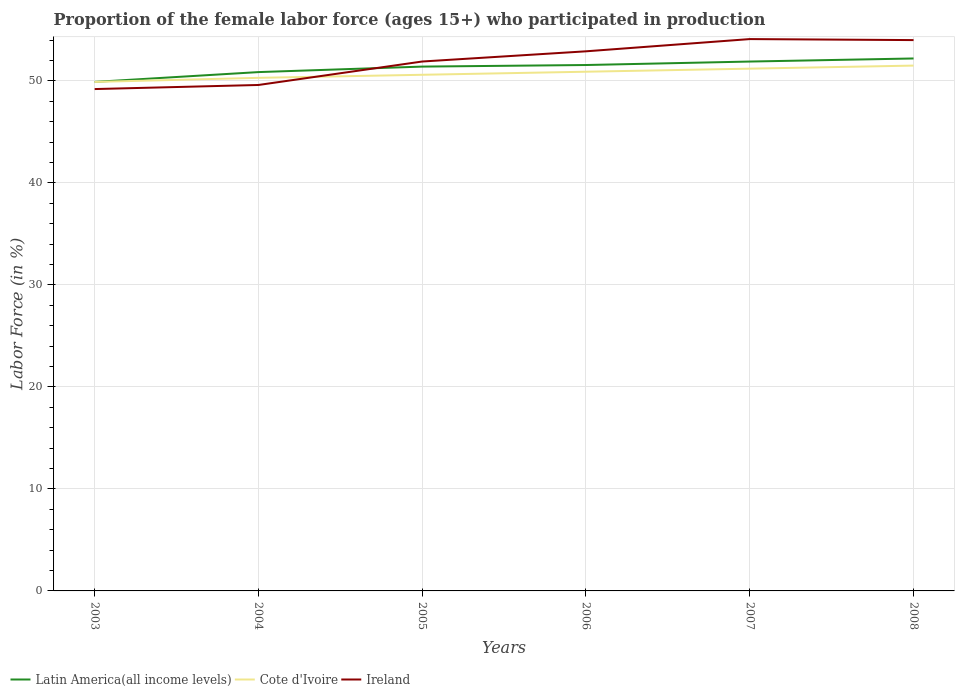Does the line corresponding to Ireland intersect with the line corresponding to Cote d'Ivoire?
Give a very brief answer. Yes. Across all years, what is the maximum proportion of the female labor force who participated in production in Cote d'Ivoire?
Your response must be concise. 49.9. In which year was the proportion of the female labor force who participated in production in Cote d'Ivoire maximum?
Provide a succinct answer. 2003. What is the total proportion of the female labor force who participated in production in Cote d'Ivoire in the graph?
Ensure brevity in your answer.  -0.4. What is the difference between the highest and the second highest proportion of the female labor force who participated in production in Ireland?
Keep it short and to the point. 4.9. What is the difference between the highest and the lowest proportion of the female labor force who participated in production in Cote d'Ivoire?
Make the answer very short. 3. How many years are there in the graph?
Offer a terse response. 6. What is the difference between two consecutive major ticks on the Y-axis?
Offer a terse response. 10. Are the values on the major ticks of Y-axis written in scientific E-notation?
Your answer should be very brief. No. Where does the legend appear in the graph?
Give a very brief answer. Bottom left. What is the title of the graph?
Offer a terse response. Proportion of the female labor force (ages 15+) who participated in production. Does "Moldova" appear as one of the legend labels in the graph?
Your response must be concise. No. What is the label or title of the X-axis?
Give a very brief answer. Years. What is the Labor Force (in %) in Latin America(all income levels) in 2003?
Provide a succinct answer. 49.9. What is the Labor Force (in %) in Cote d'Ivoire in 2003?
Offer a very short reply. 49.9. What is the Labor Force (in %) in Ireland in 2003?
Provide a succinct answer. 49.2. What is the Labor Force (in %) in Latin America(all income levels) in 2004?
Ensure brevity in your answer.  50.86. What is the Labor Force (in %) of Cote d'Ivoire in 2004?
Offer a very short reply. 50.3. What is the Labor Force (in %) of Ireland in 2004?
Offer a terse response. 49.6. What is the Labor Force (in %) in Latin America(all income levels) in 2005?
Offer a very short reply. 51.4. What is the Labor Force (in %) in Cote d'Ivoire in 2005?
Your answer should be very brief. 50.6. What is the Labor Force (in %) in Ireland in 2005?
Provide a short and direct response. 51.9. What is the Labor Force (in %) of Latin America(all income levels) in 2006?
Make the answer very short. 51.56. What is the Labor Force (in %) in Cote d'Ivoire in 2006?
Your answer should be very brief. 50.9. What is the Labor Force (in %) of Ireland in 2006?
Your answer should be very brief. 52.9. What is the Labor Force (in %) of Latin America(all income levels) in 2007?
Give a very brief answer. 51.9. What is the Labor Force (in %) in Cote d'Ivoire in 2007?
Ensure brevity in your answer.  51.2. What is the Labor Force (in %) of Ireland in 2007?
Provide a succinct answer. 54.1. What is the Labor Force (in %) in Latin America(all income levels) in 2008?
Provide a short and direct response. 52.2. What is the Labor Force (in %) of Cote d'Ivoire in 2008?
Offer a terse response. 51.5. Across all years, what is the maximum Labor Force (in %) of Latin America(all income levels)?
Your answer should be compact. 52.2. Across all years, what is the maximum Labor Force (in %) in Cote d'Ivoire?
Give a very brief answer. 51.5. Across all years, what is the maximum Labor Force (in %) of Ireland?
Give a very brief answer. 54.1. Across all years, what is the minimum Labor Force (in %) in Latin America(all income levels)?
Your response must be concise. 49.9. Across all years, what is the minimum Labor Force (in %) of Cote d'Ivoire?
Your response must be concise. 49.9. Across all years, what is the minimum Labor Force (in %) in Ireland?
Make the answer very short. 49.2. What is the total Labor Force (in %) of Latin America(all income levels) in the graph?
Your answer should be very brief. 307.82. What is the total Labor Force (in %) in Cote d'Ivoire in the graph?
Your response must be concise. 304.4. What is the total Labor Force (in %) in Ireland in the graph?
Your answer should be very brief. 311.7. What is the difference between the Labor Force (in %) of Latin America(all income levels) in 2003 and that in 2004?
Offer a very short reply. -0.96. What is the difference between the Labor Force (in %) in Cote d'Ivoire in 2003 and that in 2004?
Provide a succinct answer. -0.4. What is the difference between the Labor Force (in %) of Ireland in 2003 and that in 2004?
Ensure brevity in your answer.  -0.4. What is the difference between the Labor Force (in %) in Latin America(all income levels) in 2003 and that in 2005?
Keep it short and to the point. -1.5. What is the difference between the Labor Force (in %) of Ireland in 2003 and that in 2005?
Provide a succinct answer. -2.7. What is the difference between the Labor Force (in %) of Latin America(all income levels) in 2003 and that in 2006?
Offer a very short reply. -1.66. What is the difference between the Labor Force (in %) in Latin America(all income levels) in 2003 and that in 2007?
Give a very brief answer. -2. What is the difference between the Labor Force (in %) of Cote d'Ivoire in 2003 and that in 2007?
Keep it short and to the point. -1.3. What is the difference between the Labor Force (in %) in Latin America(all income levels) in 2003 and that in 2008?
Give a very brief answer. -2.3. What is the difference between the Labor Force (in %) of Latin America(all income levels) in 2004 and that in 2005?
Provide a short and direct response. -0.54. What is the difference between the Labor Force (in %) in Cote d'Ivoire in 2004 and that in 2005?
Ensure brevity in your answer.  -0.3. What is the difference between the Labor Force (in %) in Latin America(all income levels) in 2004 and that in 2006?
Your answer should be very brief. -0.69. What is the difference between the Labor Force (in %) in Ireland in 2004 and that in 2006?
Provide a short and direct response. -3.3. What is the difference between the Labor Force (in %) of Latin America(all income levels) in 2004 and that in 2007?
Provide a succinct answer. -1.03. What is the difference between the Labor Force (in %) of Cote d'Ivoire in 2004 and that in 2007?
Provide a succinct answer. -0.9. What is the difference between the Labor Force (in %) in Latin America(all income levels) in 2004 and that in 2008?
Your response must be concise. -1.34. What is the difference between the Labor Force (in %) in Cote d'Ivoire in 2004 and that in 2008?
Make the answer very short. -1.2. What is the difference between the Labor Force (in %) of Ireland in 2004 and that in 2008?
Your answer should be compact. -4.4. What is the difference between the Labor Force (in %) of Latin America(all income levels) in 2005 and that in 2006?
Offer a terse response. -0.16. What is the difference between the Labor Force (in %) in Cote d'Ivoire in 2005 and that in 2006?
Offer a very short reply. -0.3. What is the difference between the Labor Force (in %) of Latin America(all income levels) in 2005 and that in 2007?
Ensure brevity in your answer.  -0.49. What is the difference between the Labor Force (in %) in Latin America(all income levels) in 2005 and that in 2008?
Your answer should be compact. -0.8. What is the difference between the Labor Force (in %) in Ireland in 2005 and that in 2008?
Give a very brief answer. -2.1. What is the difference between the Labor Force (in %) of Latin America(all income levels) in 2006 and that in 2007?
Offer a terse response. -0.34. What is the difference between the Labor Force (in %) of Latin America(all income levels) in 2006 and that in 2008?
Provide a succinct answer. -0.64. What is the difference between the Labor Force (in %) of Cote d'Ivoire in 2006 and that in 2008?
Provide a succinct answer. -0.6. What is the difference between the Labor Force (in %) of Ireland in 2006 and that in 2008?
Provide a short and direct response. -1.1. What is the difference between the Labor Force (in %) of Latin America(all income levels) in 2007 and that in 2008?
Offer a terse response. -0.3. What is the difference between the Labor Force (in %) of Latin America(all income levels) in 2003 and the Labor Force (in %) of Cote d'Ivoire in 2004?
Keep it short and to the point. -0.4. What is the difference between the Labor Force (in %) of Latin America(all income levels) in 2003 and the Labor Force (in %) of Ireland in 2004?
Provide a short and direct response. 0.3. What is the difference between the Labor Force (in %) in Cote d'Ivoire in 2003 and the Labor Force (in %) in Ireland in 2004?
Offer a terse response. 0.3. What is the difference between the Labor Force (in %) of Latin America(all income levels) in 2003 and the Labor Force (in %) of Cote d'Ivoire in 2005?
Provide a short and direct response. -0.7. What is the difference between the Labor Force (in %) of Latin America(all income levels) in 2003 and the Labor Force (in %) of Ireland in 2005?
Ensure brevity in your answer.  -2. What is the difference between the Labor Force (in %) in Latin America(all income levels) in 2003 and the Labor Force (in %) in Cote d'Ivoire in 2006?
Keep it short and to the point. -1. What is the difference between the Labor Force (in %) in Latin America(all income levels) in 2003 and the Labor Force (in %) in Ireland in 2006?
Provide a short and direct response. -3. What is the difference between the Labor Force (in %) in Latin America(all income levels) in 2003 and the Labor Force (in %) in Cote d'Ivoire in 2007?
Your response must be concise. -1.3. What is the difference between the Labor Force (in %) in Latin America(all income levels) in 2003 and the Labor Force (in %) in Ireland in 2007?
Your answer should be compact. -4.2. What is the difference between the Labor Force (in %) of Cote d'Ivoire in 2003 and the Labor Force (in %) of Ireland in 2007?
Make the answer very short. -4.2. What is the difference between the Labor Force (in %) of Latin America(all income levels) in 2003 and the Labor Force (in %) of Cote d'Ivoire in 2008?
Keep it short and to the point. -1.6. What is the difference between the Labor Force (in %) in Latin America(all income levels) in 2003 and the Labor Force (in %) in Ireland in 2008?
Offer a terse response. -4.1. What is the difference between the Labor Force (in %) in Latin America(all income levels) in 2004 and the Labor Force (in %) in Cote d'Ivoire in 2005?
Ensure brevity in your answer.  0.26. What is the difference between the Labor Force (in %) of Latin America(all income levels) in 2004 and the Labor Force (in %) of Ireland in 2005?
Provide a short and direct response. -1.04. What is the difference between the Labor Force (in %) in Latin America(all income levels) in 2004 and the Labor Force (in %) in Cote d'Ivoire in 2006?
Provide a succinct answer. -0.04. What is the difference between the Labor Force (in %) of Latin America(all income levels) in 2004 and the Labor Force (in %) of Ireland in 2006?
Provide a succinct answer. -2.04. What is the difference between the Labor Force (in %) of Cote d'Ivoire in 2004 and the Labor Force (in %) of Ireland in 2006?
Make the answer very short. -2.6. What is the difference between the Labor Force (in %) of Latin America(all income levels) in 2004 and the Labor Force (in %) of Cote d'Ivoire in 2007?
Give a very brief answer. -0.34. What is the difference between the Labor Force (in %) in Latin America(all income levels) in 2004 and the Labor Force (in %) in Ireland in 2007?
Provide a succinct answer. -3.24. What is the difference between the Labor Force (in %) in Latin America(all income levels) in 2004 and the Labor Force (in %) in Cote d'Ivoire in 2008?
Make the answer very short. -0.64. What is the difference between the Labor Force (in %) of Latin America(all income levels) in 2004 and the Labor Force (in %) of Ireland in 2008?
Your answer should be very brief. -3.14. What is the difference between the Labor Force (in %) in Cote d'Ivoire in 2004 and the Labor Force (in %) in Ireland in 2008?
Your answer should be compact. -3.7. What is the difference between the Labor Force (in %) of Latin America(all income levels) in 2005 and the Labor Force (in %) of Cote d'Ivoire in 2006?
Your answer should be compact. 0.5. What is the difference between the Labor Force (in %) in Latin America(all income levels) in 2005 and the Labor Force (in %) in Ireland in 2006?
Make the answer very short. -1.5. What is the difference between the Labor Force (in %) in Latin America(all income levels) in 2005 and the Labor Force (in %) in Cote d'Ivoire in 2007?
Offer a very short reply. 0.2. What is the difference between the Labor Force (in %) in Latin America(all income levels) in 2005 and the Labor Force (in %) in Ireland in 2007?
Offer a very short reply. -2.7. What is the difference between the Labor Force (in %) of Latin America(all income levels) in 2005 and the Labor Force (in %) of Cote d'Ivoire in 2008?
Offer a very short reply. -0.1. What is the difference between the Labor Force (in %) of Latin America(all income levels) in 2005 and the Labor Force (in %) of Ireland in 2008?
Your answer should be compact. -2.6. What is the difference between the Labor Force (in %) of Cote d'Ivoire in 2005 and the Labor Force (in %) of Ireland in 2008?
Make the answer very short. -3.4. What is the difference between the Labor Force (in %) in Latin America(all income levels) in 2006 and the Labor Force (in %) in Cote d'Ivoire in 2007?
Offer a very short reply. 0.36. What is the difference between the Labor Force (in %) of Latin America(all income levels) in 2006 and the Labor Force (in %) of Ireland in 2007?
Your answer should be compact. -2.54. What is the difference between the Labor Force (in %) in Latin America(all income levels) in 2006 and the Labor Force (in %) in Cote d'Ivoire in 2008?
Provide a succinct answer. 0.06. What is the difference between the Labor Force (in %) of Latin America(all income levels) in 2006 and the Labor Force (in %) of Ireland in 2008?
Keep it short and to the point. -2.44. What is the difference between the Labor Force (in %) of Latin America(all income levels) in 2007 and the Labor Force (in %) of Cote d'Ivoire in 2008?
Offer a terse response. 0.4. What is the difference between the Labor Force (in %) of Latin America(all income levels) in 2007 and the Labor Force (in %) of Ireland in 2008?
Make the answer very short. -2.1. What is the average Labor Force (in %) of Latin America(all income levels) per year?
Offer a very short reply. 51.3. What is the average Labor Force (in %) of Cote d'Ivoire per year?
Make the answer very short. 50.73. What is the average Labor Force (in %) in Ireland per year?
Offer a terse response. 51.95. In the year 2003, what is the difference between the Labor Force (in %) in Latin America(all income levels) and Labor Force (in %) in Cote d'Ivoire?
Keep it short and to the point. 0. In the year 2003, what is the difference between the Labor Force (in %) of Latin America(all income levels) and Labor Force (in %) of Ireland?
Your answer should be very brief. 0.7. In the year 2004, what is the difference between the Labor Force (in %) in Latin America(all income levels) and Labor Force (in %) in Cote d'Ivoire?
Offer a very short reply. 0.56. In the year 2004, what is the difference between the Labor Force (in %) in Latin America(all income levels) and Labor Force (in %) in Ireland?
Provide a succinct answer. 1.26. In the year 2005, what is the difference between the Labor Force (in %) of Latin America(all income levels) and Labor Force (in %) of Cote d'Ivoire?
Offer a terse response. 0.8. In the year 2005, what is the difference between the Labor Force (in %) of Latin America(all income levels) and Labor Force (in %) of Ireland?
Ensure brevity in your answer.  -0.5. In the year 2005, what is the difference between the Labor Force (in %) of Cote d'Ivoire and Labor Force (in %) of Ireland?
Offer a very short reply. -1.3. In the year 2006, what is the difference between the Labor Force (in %) in Latin America(all income levels) and Labor Force (in %) in Cote d'Ivoire?
Keep it short and to the point. 0.66. In the year 2006, what is the difference between the Labor Force (in %) of Latin America(all income levels) and Labor Force (in %) of Ireland?
Your response must be concise. -1.34. In the year 2006, what is the difference between the Labor Force (in %) in Cote d'Ivoire and Labor Force (in %) in Ireland?
Offer a very short reply. -2. In the year 2007, what is the difference between the Labor Force (in %) of Latin America(all income levels) and Labor Force (in %) of Cote d'Ivoire?
Provide a succinct answer. 0.7. In the year 2007, what is the difference between the Labor Force (in %) in Latin America(all income levels) and Labor Force (in %) in Ireland?
Keep it short and to the point. -2.2. In the year 2007, what is the difference between the Labor Force (in %) in Cote d'Ivoire and Labor Force (in %) in Ireland?
Your answer should be very brief. -2.9. In the year 2008, what is the difference between the Labor Force (in %) of Latin America(all income levels) and Labor Force (in %) of Cote d'Ivoire?
Offer a terse response. 0.7. In the year 2008, what is the difference between the Labor Force (in %) of Latin America(all income levels) and Labor Force (in %) of Ireland?
Offer a terse response. -1.8. In the year 2008, what is the difference between the Labor Force (in %) in Cote d'Ivoire and Labor Force (in %) in Ireland?
Your response must be concise. -2.5. What is the ratio of the Labor Force (in %) of Latin America(all income levels) in 2003 to that in 2004?
Make the answer very short. 0.98. What is the ratio of the Labor Force (in %) in Ireland in 2003 to that in 2004?
Offer a terse response. 0.99. What is the ratio of the Labor Force (in %) of Latin America(all income levels) in 2003 to that in 2005?
Provide a short and direct response. 0.97. What is the ratio of the Labor Force (in %) in Cote d'Ivoire in 2003 to that in 2005?
Provide a succinct answer. 0.99. What is the ratio of the Labor Force (in %) of Ireland in 2003 to that in 2005?
Make the answer very short. 0.95. What is the ratio of the Labor Force (in %) in Latin America(all income levels) in 2003 to that in 2006?
Provide a short and direct response. 0.97. What is the ratio of the Labor Force (in %) in Cote d'Ivoire in 2003 to that in 2006?
Keep it short and to the point. 0.98. What is the ratio of the Labor Force (in %) of Ireland in 2003 to that in 2006?
Provide a succinct answer. 0.93. What is the ratio of the Labor Force (in %) of Latin America(all income levels) in 2003 to that in 2007?
Offer a terse response. 0.96. What is the ratio of the Labor Force (in %) in Cote d'Ivoire in 2003 to that in 2007?
Offer a very short reply. 0.97. What is the ratio of the Labor Force (in %) in Ireland in 2003 to that in 2007?
Provide a succinct answer. 0.91. What is the ratio of the Labor Force (in %) in Latin America(all income levels) in 2003 to that in 2008?
Keep it short and to the point. 0.96. What is the ratio of the Labor Force (in %) in Cote d'Ivoire in 2003 to that in 2008?
Your answer should be compact. 0.97. What is the ratio of the Labor Force (in %) of Ireland in 2003 to that in 2008?
Your response must be concise. 0.91. What is the ratio of the Labor Force (in %) in Ireland in 2004 to that in 2005?
Ensure brevity in your answer.  0.96. What is the ratio of the Labor Force (in %) of Latin America(all income levels) in 2004 to that in 2006?
Keep it short and to the point. 0.99. What is the ratio of the Labor Force (in %) in Ireland in 2004 to that in 2006?
Provide a short and direct response. 0.94. What is the ratio of the Labor Force (in %) of Latin America(all income levels) in 2004 to that in 2007?
Provide a succinct answer. 0.98. What is the ratio of the Labor Force (in %) in Cote d'Ivoire in 2004 to that in 2007?
Make the answer very short. 0.98. What is the ratio of the Labor Force (in %) of Ireland in 2004 to that in 2007?
Offer a very short reply. 0.92. What is the ratio of the Labor Force (in %) in Latin America(all income levels) in 2004 to that in 2008?
Keep it short and to the point. 0.97. What is the ratio of the Labor Force (in %) of Cote d'Ivoire in 2004 to that in 2008?
Give a very brief answer. 0.98. What is the ratio of the Labor Force (in %) of Ireland in 2004 to that in 2008?
Your answer should be compact. 0.92. What is the ratio of the Labor Force (in %) in Latin America(all income levels) in 2005 to that in 2006?
Offer a very short reply. 1. What is the ratio of the Labor Force (in %) of Cote d'Ivoire in 2005 to that in 2006?
Your response must be concise. 0.99. What is the ratio of the Labor Force (in %) in Ireland in 2005 to that in 2006?
Your answer should be very brief. 0.98. What is the ratio of the Labor Force (in %) of Cote d'Ivoire in 2005 to that in 2007?
Offer a terse response. 0.99. What is the ratio of the Labor Force (in %) of Ireland in 2005 to that in 2007?
Keep it short and to the point. 0.96. What is the ratio of the Labor Force (in %) in Latin America(all income levels) in 2005 to that in 2008?
Provide a succinct answer. 0.98. What is the ratio of the Labor Force (in %) of Cote d'Ivoire in 2005 to that in 2008?
Provide a short and direct response. 0.98. What is the ratio of the Labor Force (in %) in Ireland in 2005 to that in 2008?
Make the answer very short. 0.96. What is the ratio of the Labor Force (in %) of Latin America(all income levels) in 2006 to that in 2007?
Provide a succinct answer. 0.99. What is the ratio of the Labor Force (in %) in Cote d'Ivoire in 2006 to that in 2007?
Your answer should be compact. 0.99. What is the ratio of the Labor Force (in %) in Ireland in 2006 to that in 2007?
Your answer should be very brief. 0.98. What is the ratio of the Labor Force (in %) in Latin America(all income levels) in 2006 to that in 2008?
Your response must be concise. 0.99. What is the ratio of the Labor Force (in %) in Cote d'Ivoire in 2006 to that in 2008?
Provide a short and direct response. 0.99. What is the ratio of the Labor Force (in %) in Ireland in 2006 to that in 2008?
Keep it short and to the point. 0.98. What is the ratio of the Labor Force (in %) in Latin America(all income levels) in 2007 to that in 2008?
Your answer should be compact. 0.99. What is the ratio of the Labor Force (in %) in Ireland in 2007 to that in 2008?
Your answer should be compact. 1. What is the difference between the highest and the second highest Labor Force (in %) of Latin America(all income levels)?
Your answer should be very brief. 0.3. What is the difference between the highest and the second highest Labor Force (in %) of Cote d'Ivoire?
Your response must be concise. 0.3. What is the difference between the highest and the lowest Labor Force (in %) in Latin America(all income levels)?
Keep it short and to the point. 2.3. What is the difference between the highest and the lowest Labor Force (in %) of Ireland?
Provide a short and direct response. 4.9. 